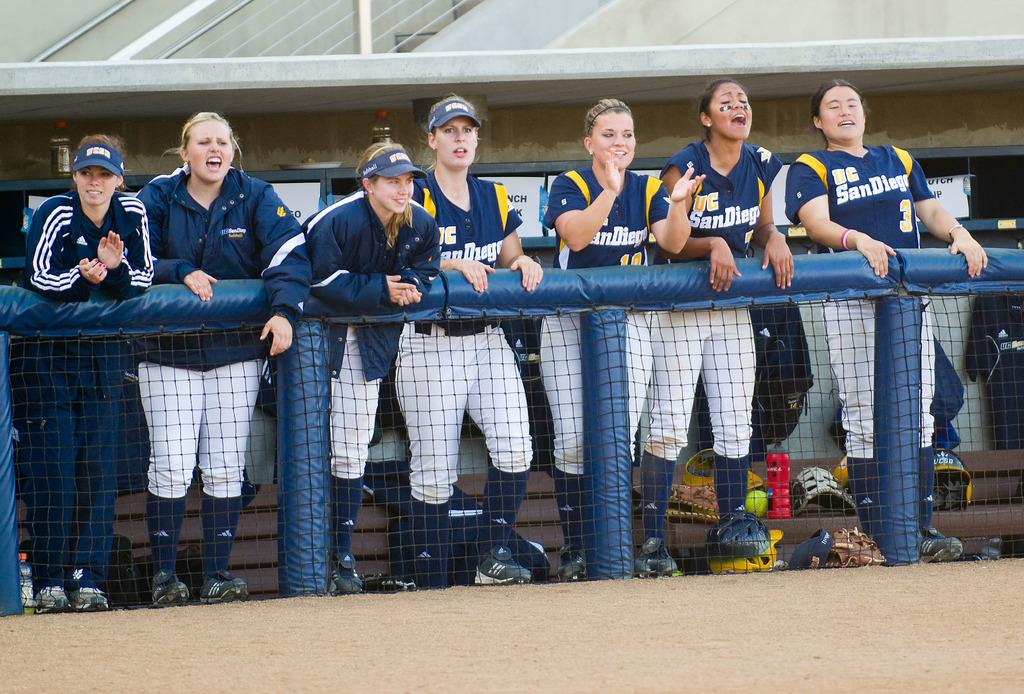What are the people in the image doing? The people in the image are standing. What is in front of the people? There is a net in front of the people. What objects are visible on a surface in the image? Helmets are visible on a surface. What can be seen in the background of the image? There is a wall in the background of the image. What statement can be heard from the person holding the rake in the image? There is no person holding a rake in the image, and therefore no statement can be heard. 